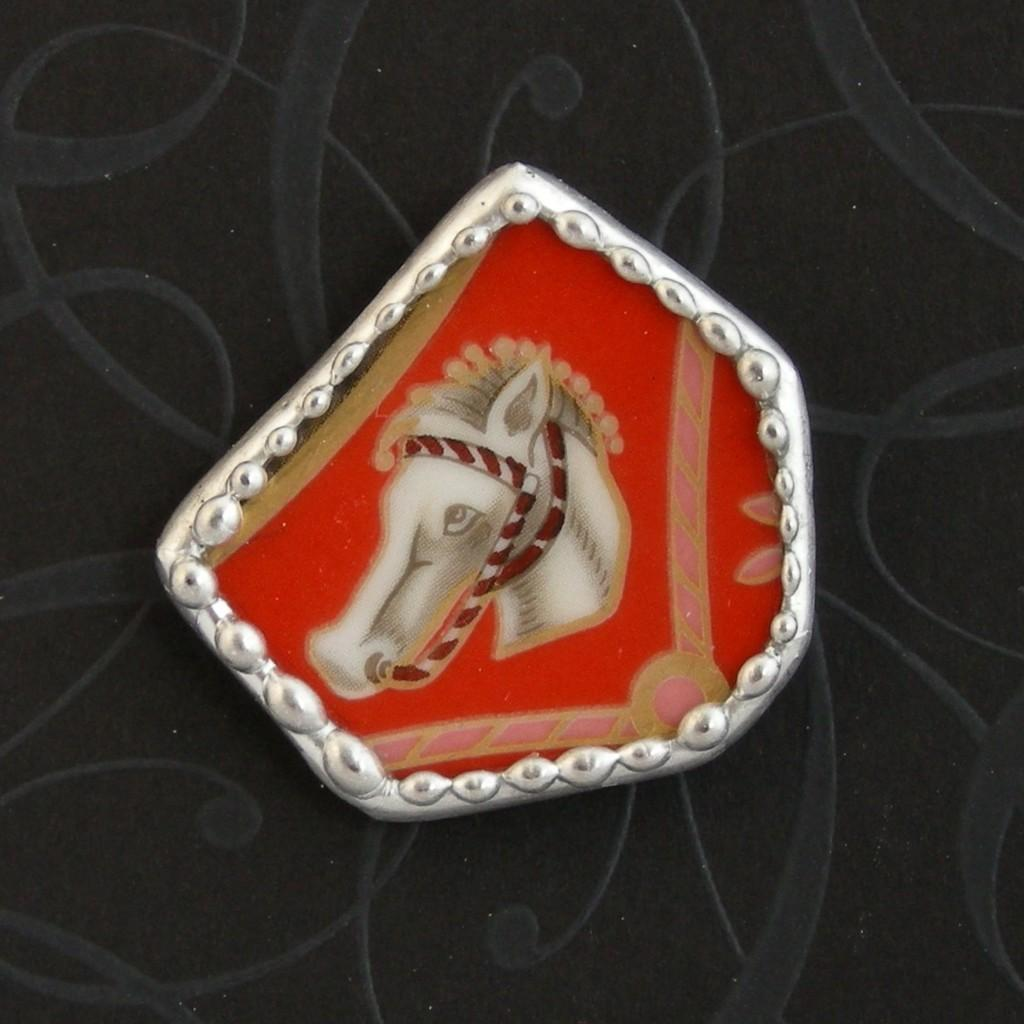What is the main subject of the image? The main subject of the image is a batch. What is depicted on the batch? The batch has a depiction of a horse. What is the color of the background in the image? The background of the image is black in color. How many beans are visible on the horse in the image? There are no beans present in the image; it features a batch with a depiction of a horse on a black background. What type of school is depicted in the image? There is no school depicted in the image; it features a batch with a depiction of a horse on a black background. 